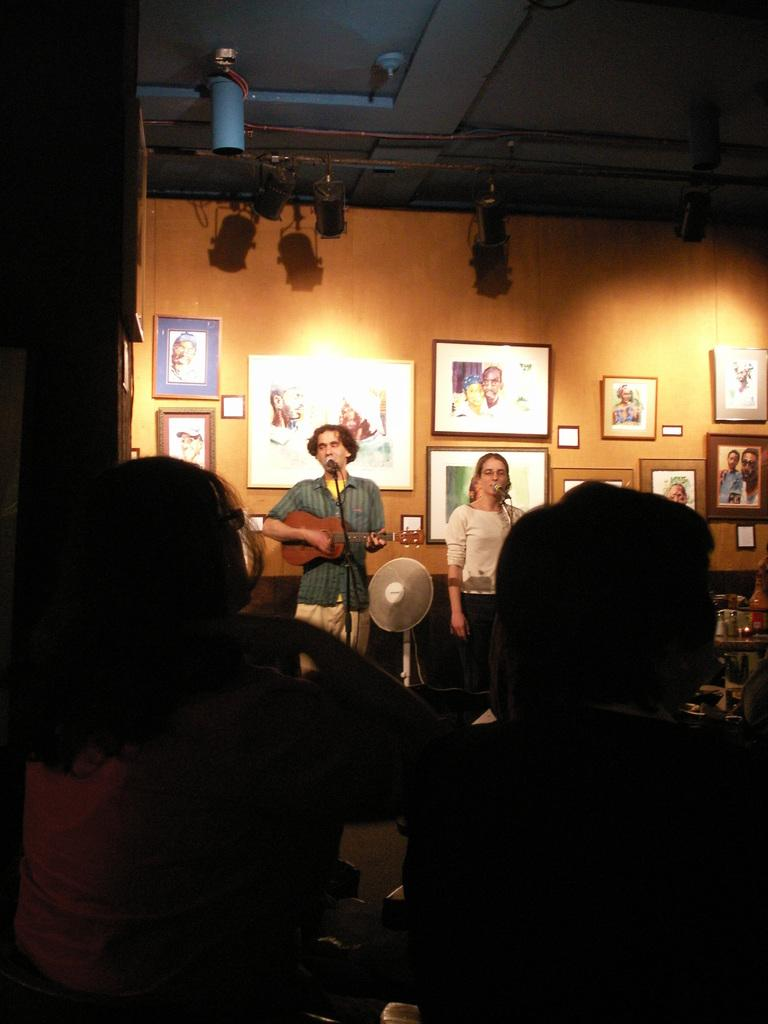What is the main activity being performed by the person on the left side of the image? The person on the left side of the image is playing guitar. What else is the person on the left side doing? The person on the left side is also singing. Where is the person playing guitar located in relation to the mic? The person playing guitar is in front of a mic. Can you describe the position of the second person in the image? The second person is on the right side of the image and is also singing. Is the second person also in front of a mic? Yes, the second person is also in front of a mic. What is the audience doing in the image? There are people sitting in front of the two singers. What time does the clock on the sidewalk show in the image? There is no clock or sidewalk present in the image. What type of arithmetic problem is being solved by the person playing guitar? There is no arithmetic problem being solved in the image; the person is playing guitar and singing. 